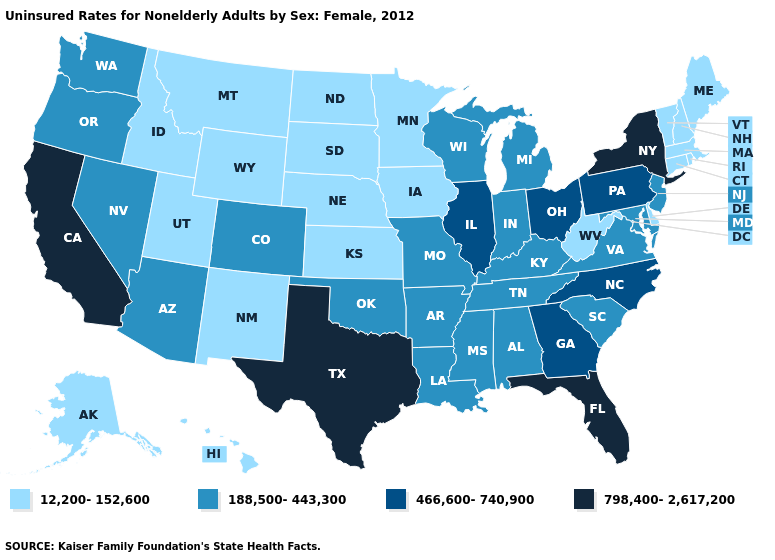What is the value of Wyoming?
Quick response, please. 12,200-152,600. Name the states that have a value in the range 12,200-152,600?
Give a very brief answer. Alaska, Connecticut, Delaware, Hawaii, Idaho, Iowa, Kansas, Maine, Massachusetts, Minnesota, Montana, Nebraska, New Hampshire, New Mexico, North Dakota, Rhode Island, South Dakota, Utah, Vermont, West Virginia, Wyoming. Among the states that border Florida , which have the lowest value?
Give a very brief answer. Alabama. Does North Carolina have the same value as Pennsylvania?
Give a very brief answer. Yes. Does the map have missing data?
Concise answer only. No. What is the value of Iowa?
Keep it brief. 12,200-152,600. Name the states that have a value in the range 466,600-740,900?
Write a very short answer. Georgia, Illinois, North Carolina, Ohio, Pennsylvania. Name the states that have a value in the range 798,400-2,617,200?
Quick response, please. California, Florida, New York, Texas. Does Alaska have the lowest value in the USA?
Answer briefly. Yes. Among the states that border Wisconsin , which have the highest value?
Write a very short answer. Illinois. Name the states that have a value in the range 12,200-152,600?
Write a very short answer. Alaska, Connecticut, Delaware, Hawaii, Idaho, Iowa, Kansas, Maine, Massachusetts, Minnesota, Montana, Nebraska, New Hampshire, New Mexico, North Dakota, Rhode Island, South Dakota, Utah, Vermont, West Virginia, Wyoming. Among the states that border Florida , does Georgia have the lowest value?
Answer briefly. No. What is the lowest value in states that border New Hampshire?
Concise answer only. 12,200-152,600. Does Vermont have a lower value than New York?
Keep it brief. Yes. Which states have the highest value in the USA?
Short answer required. California, Florida, New York, Texas. 